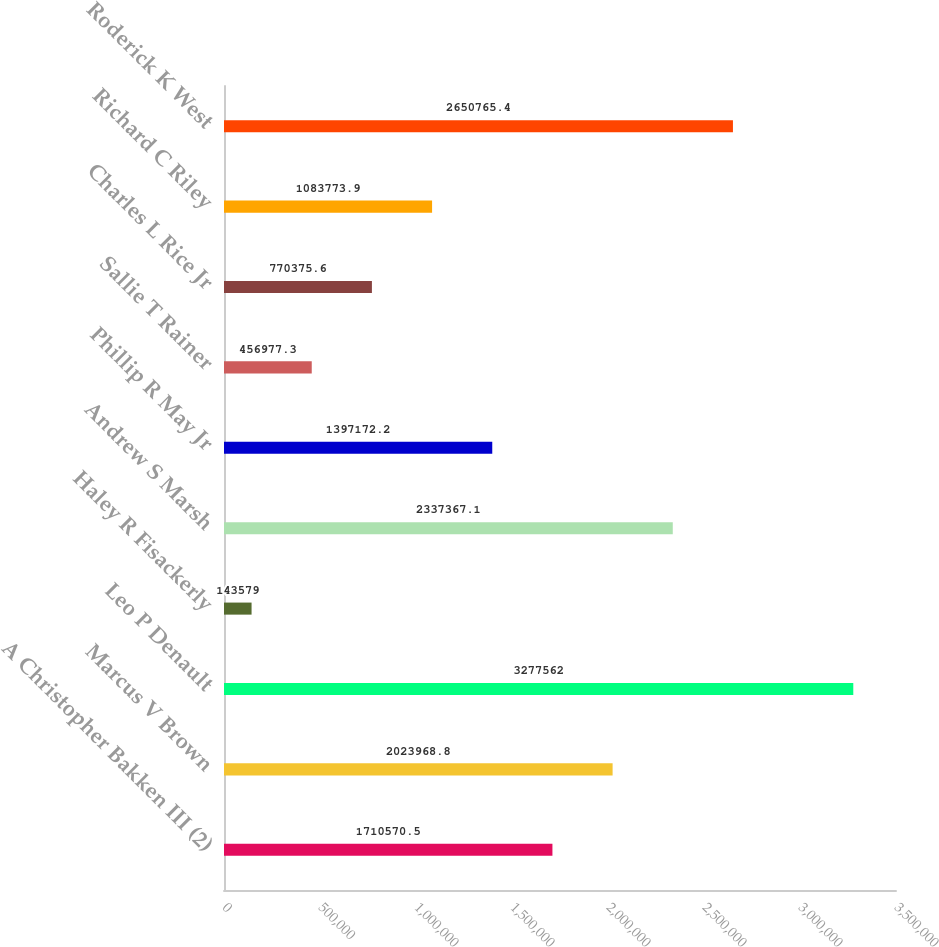<chart> <loc_0><loc_0><loc_500><loc_500><bar_chart><fcel>A Christopher Bakken III (2)<fcel>Marcus V Brown<fcel>Leo P Denault<fcel>Haley R Fisackerly<fcel>Andrew S Marsh<fcel>Phillip R May Jr<fcel>Sallie T Rainer<fcel>Charles L Rice Jr<fcel>Richard C Riley<fcel>Roderick K West<nl><fcel>1.71057e+06<fcel>2.02397e+06<fcel>3.27756e+06<fcel>143579<fcel>2.33737e+06<fcel>1.39717e+06<fcel>456977<fcel>770376<fcel>1.08377e+06<fcel>2.65077e+06<nl></chart> 